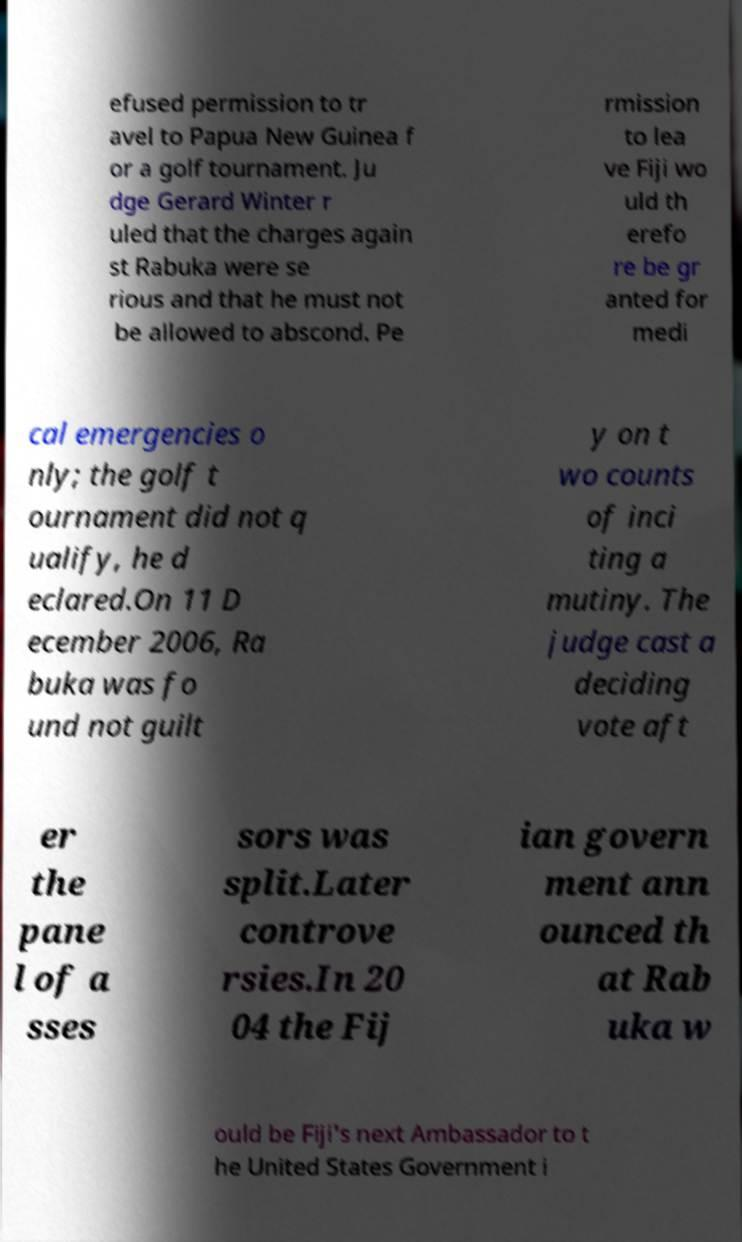Could you assist in decoding the text presented in this image and type it out clearly? efused permission to tr avel to Papua New Guinea f or a golf tournament. Ju dge Gerard Winter r uled that the charges again st Rabuka were se rious and that he must not be allowed to abscond. Pe rmission to lea ve Fiji wo uld th erefo re be gr anted for medi cal emergencies o nly; the golf t ournament did not q ualify, he d eclared.On 11 D ecember 2006, Ra buka was fo und not guilt y on t wo counts of inci ting a mutiny. The judge cast a deciding vote aft er the pane l of a sses sors was split.Later controve rsies.In 20 04 the Fij ian govern ment ann ounced th at Rab uka w ould be Fiji's next Ambassador to t he United States Government i 